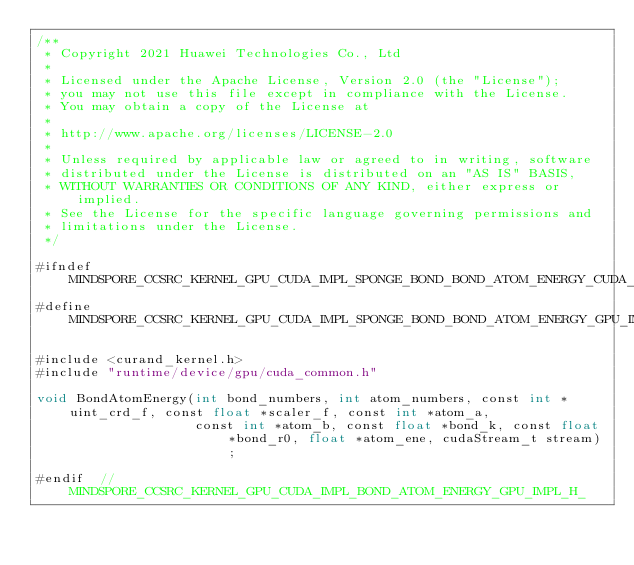Convert code to text. <code><loc_0><loc_0><loc_500><loc_500><_Cuda_>/**
 * Copyright 2021 Huawei Technologies Co., Ltd
 *
 * Licensed under the Apache License, Version 2.0 (the "License");
 * you may not use this file except in compliance with the License.
 * You may obtain a copy of the License at
 *
 * http://www.apache.org/licenses/LICENSE-2.0
 *
 * Unless required by applicable law or agreed to in writing, software
 * distributed under the License is distributed on an "AS IS" BASIS,
 * WITHOUT WARRANTIES OR CONDITIONS OF ANY KIND, either express or implied.
 * See the License for the specific language governing permissions and
 * limitations under the License.
 */

#ifndef MINDSPORE_CCSRC_KERNEL_GPU_CUDA_IMPL_SPONGE_BOND_BOND_ATOM_ENERGY_CUDA_GPU_IMPL_H_
#define MINDSPORE_CCSRC_KERNEL_GPU_CUDA_IMPL_SPONGE_BOND_BOND_ATOM_ENERGY_GPU_IMPL_H_

#include <curand_kernel.h>
#include "runtime/device/gpu/cuda_common.h"

void BondAtomEnergy(int bond_numbers, int atom_numbers, const int *uint_crd_f, const float *scaler_f, const int *atom_a,
                    const int *atom_b, const float *bond_k, const float *bond_r0, float *atom_ene, cudaStream_t stream);

#endif  // MINDSPORE_CCSRC_KERNEL_GPU_CUDA_IMPL_BOND_ATOM_ENERGY_GPU_IMPL_H_
</code> 